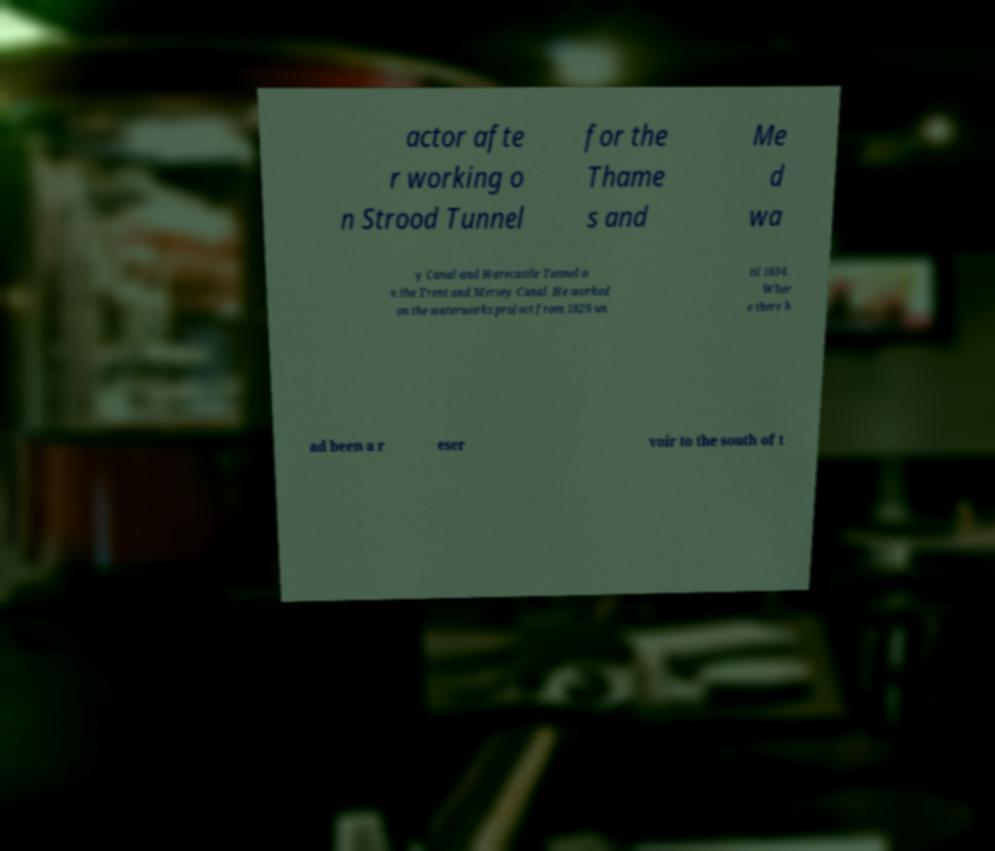Please read and relay the text visible in this image. What does it say? actor afte r working o n Strood Tunnel for the Thame s and Me d wa y Canal and Harecastle Tunnel o n the Trent and Mersey Canal. He worked on the waterworks project from 1829 un til 1834. Wher e there h ad been a r eser voir to the south of t 